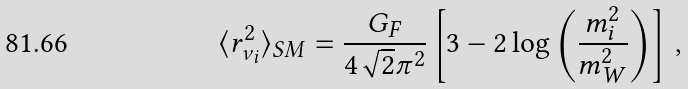Convert formula to latex. <formula><loc_0><loc_0><loc_500><loc_500>\langle r _ { \nu _ { i } } ^ { 2 } \rangle _ { S M } = \frac { G _ { F } } { 4 \sqrt { 2 } \pi ^ { 2 } } \left [ 3 - 2 \log \left ( \frac { m _ { i } ^ { 2 } } { m _ { W } ^ { 2 } } \right ) \right ] \, ,</formula> 